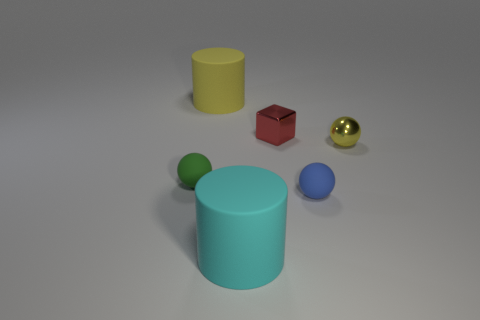Add 1 small green balls. How many objects exist? 7 Subtract all yellow balls. How many balls are left? 2 Subtract all rubber spheres. How many spheres are left? 1 Subtract all cylinders. How many objects are left? 4 Subtract 1 balls. How many balls are left? 2 Add 5 yellow things. How many yellow things are left? 7 Add 3 green objects. How many green objects exist? 4 Subtract 1 blue balls. How many objects are left? 5 Subtract all cyan balls. Subtract all cyan blocks. How many balls are left? 3 Subtract all green cylinders. How many gray blocks are left? 0 